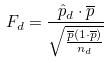Convert formula to latex. <formula><loc_0><loc_0><loc_500><loc_500>F _ { d } = \frac { \hat { p } _ { d } \cdot \overline { p } } { \sqrt { \frac { \overline { p } ( 1 \cdot \overline { p } ) } { n _ { d } } } }</formula> 